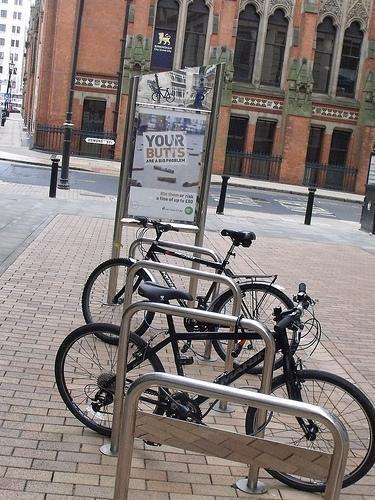How many bikes are there?
Give a very brief answer. 2. How many wheels are there?
Give a very brief answer. 4. 